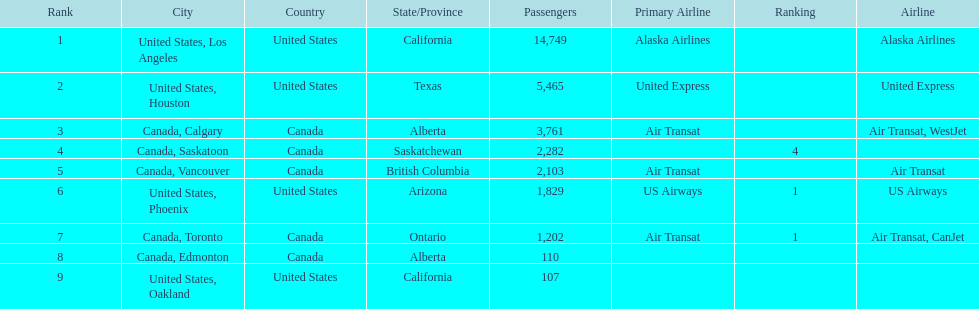The least number of passengers came from which city United States, Oakland. 